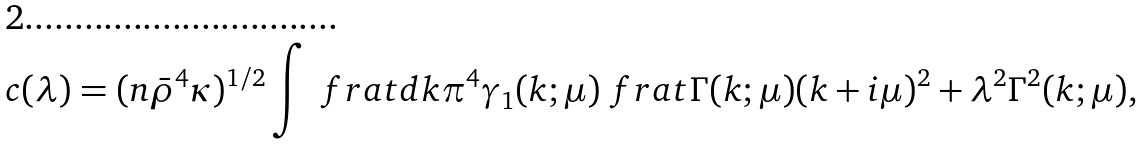Convert formula to latex. <formula><loc_0><loc_0><loc_500><loc_500>c ( \lambda ) = ( n \bar { \rho } ^ { 4 } \kappa ) ^ { 1 / 2 } \int \ f r a t { d k } { \pi ^ { 4 } } \gamma _ { 1 } ( k ; \mu ) \ f r a t { \Gamma ( k ; \mu ) } { ( k + i \mu ) ^ { 2 } + \lambda ^ { 2 } \Gamma ^ { 2 } ( k ; \mu ) } ,</formula> 